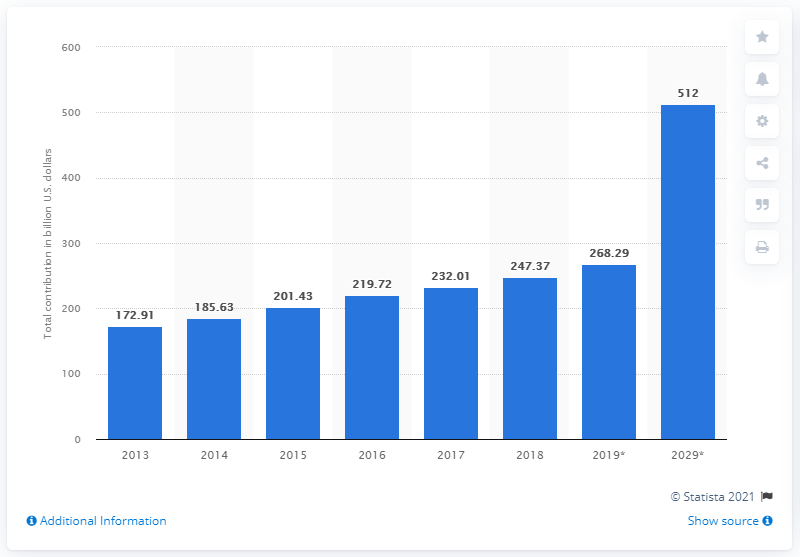Specify some key components in this picture. In 2018, the travel and tourism industry contributed 247.37% to India's GDP. 